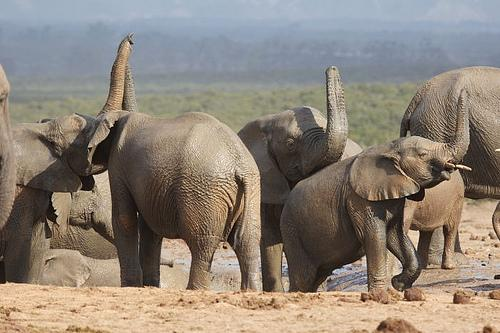What part of the body are the elephants holding up?

Choices:
A) tails
B) arms
C) ears
D) trunks trunks 